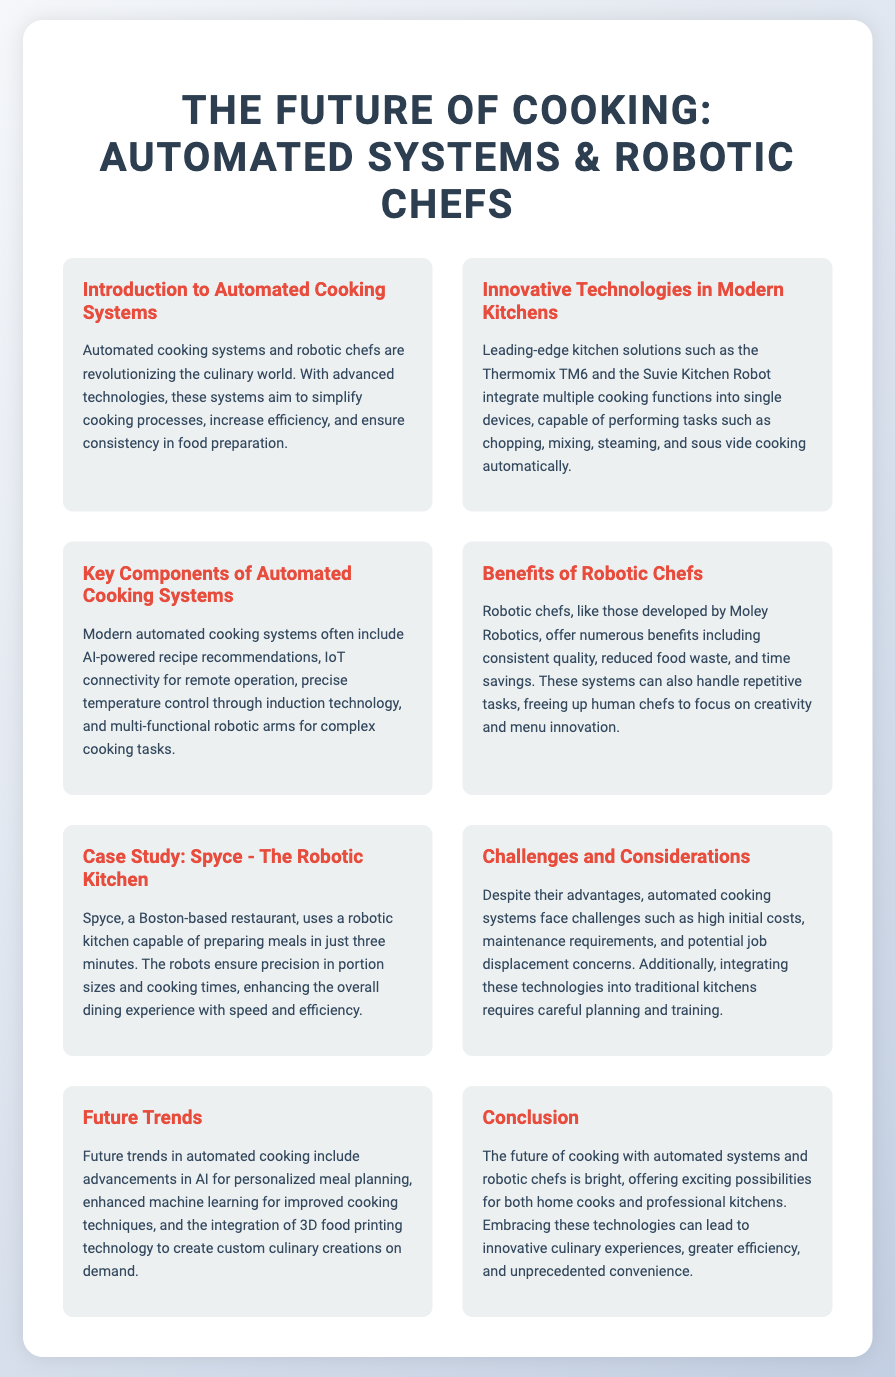What is the title of the poster? The title of the poster is indicated at the top of the document.
Answer: The Future of Cooking: Automated Systems & Robotic Chefs What is the name of the robotic kitchen in the case study? The case study mentions a specific robotic kitchen that has been implemented in a restaurant.
Answer: Spyce What is one benefit of robotic chefs mentioned in the document? The document lists several benefits of robotic chefs, specifically highlighting one in the section dedicated to them.
Answer: Consistent quality Which technology is mentioned as part of innovative kitchen solutions? The document refers to specific technologies that integrate multiple cooking functions.
Answer: Thermomix TM6 What is a future trend in automated cooking? The document outlines anticipated advancements in cooking technology; this question focuses on one trend specifically.
Answer: AI for personalized meal planning What are two challenges faced by automated cooking systems? The challenges are listed in a dedicated section, requiring identification of two notable barriers to widespread adoption.
Answer: High initial costs, maintenance requirements What kind of cooking methods do modern automated systems perform? The document describes functions related to cooking methods that are automated.
Answer: Chopping, mixing, steaming, and sous vide cooking What does the iconography in the sections symbolize? The icons used in each section visually represent the topic covered in that section of the poster.
Answer: Technologies and cooking processes 